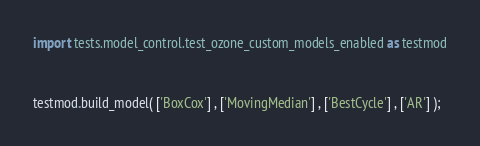<code> <loc_0><loc_0><loc_500><loc_500><_Python_>import tests.model_control.test_ozone_custom_models_enabled as testmod


testmod.build_model( ['BoxCox'] , ['MovingMedian'] , ['BestCycle'] , ['AR'] );</code> 